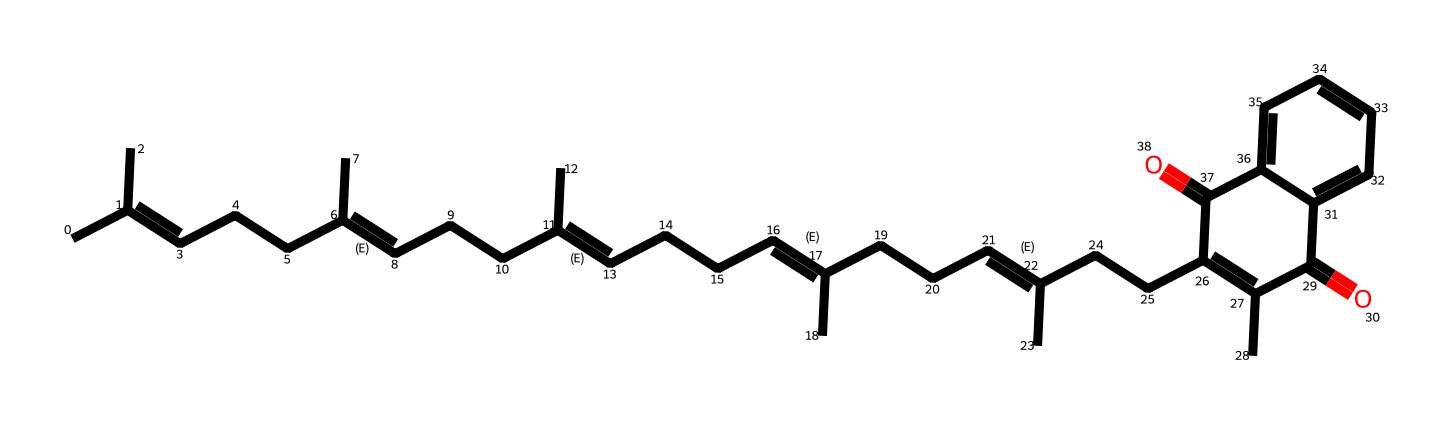How many carbon atoms are in vitamin K2? An inspection of the SMILES representation reveals that the structure consists of a long hydrocarbon chain. By counting each 'C' in the SMILES, we find a total of 27 carbon atoms.
Answer: 27 What is the molecular formula of vitamin K2? To derive the molecular formula, we gather the counts of carbon (C), hydrogen (H), and oxygen (O) from the structure. With 27 carbons, 36 hydrogens, and 2 oxygens, the molecular formula is C27H36O2.
Answer: C27H36O2 What type of functional groups are present in vitamin K2? The chemical structure contains carbonyl groups (C=O) indicated by the =O present in the molecular structure and the cyclic components, which suggests a ketone functional group.
Answer: carbonyl What are the two key properties of vitamin K2 related to its functionality? Vitamin K2's structure allows it to participate in redox reactions due to its double bonds and to act in electron transfer processes in renewable energy storage applications. These functions are essential for its biological activity and potential in energy applications.
Answer: redox reactivity, electron transfer How many rings are present in the molecular structure of vitamin K2? Reviewing the chemical structure, we can identify that there are two distinct rings present within the molecule which can be observed as cyclical segments in the SMILES string.
Answer: 2 What role does vitamin K2 play in renewable energy? Vitamin K2 is believed to have applications in energy storage systems due to its redox capabilities, which can enhance the efficiency of energy storage technologies through electron transfer functions.
Answer: electron transfer functions 